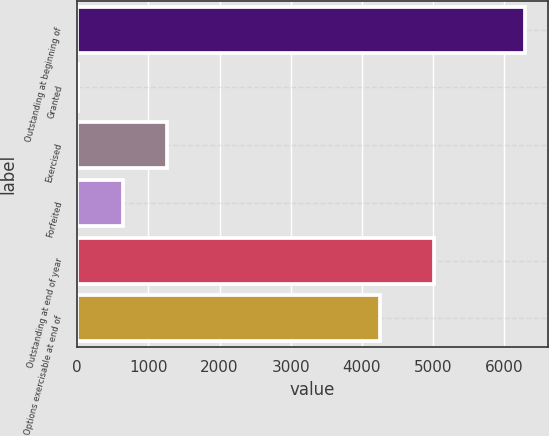Convert chart. <chart><loc_0><loc_0><loc_500><loc_500><bar_chart><fcel>Outstanding at beginning of<fcel>Granted<fcel>Exercised<fcel>Forfeited<fcel>Outstanding at end of year<fcel>Options exercisable at end of<nl><fcel>6295<fcel>10<fcel>1267<fcel>638.5<fcel>5012<fcel>4252<nl></chart> 